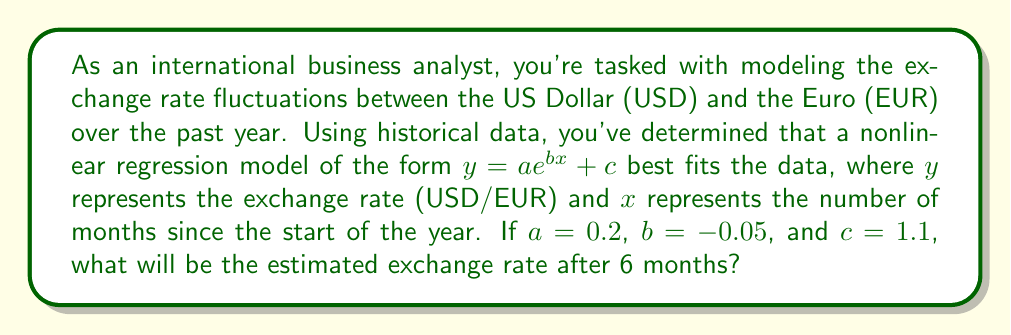Can you answer this question? To solve this problem, we'll follow these steps:

1. Identify the given nonlinear regression model:
   $y = ae^{bx} + c$

2. Substitute the given values:
   $a = 0.2$
   $b = -0.05$
   $c = 1.1$
   $x = 6$ (months)

3. Plug these values into the equation:
   $y = 0.2e^{-0.05(6)} + 1.1$

4. Simplify the exponent:
   $y = 0.2e^{-0.3} + 1.1$

5. Calculate the value of $e^{-0.3}$:
   $e^{-0.3} \approx 0.7408$ (rounded to 4 decimal places)

6. Multiply 0.2 by this value:
   $0.2 \times 0.7408 \approx 0.1482$

7. Add 1.1 to the result:
   $0.1482 + 1.1 = 1.2482$

8. Round to 4 decimal places for the final exchange rate:
   $1.2482$ USD/EUR
Answer: 1.2482 USD/EUR 